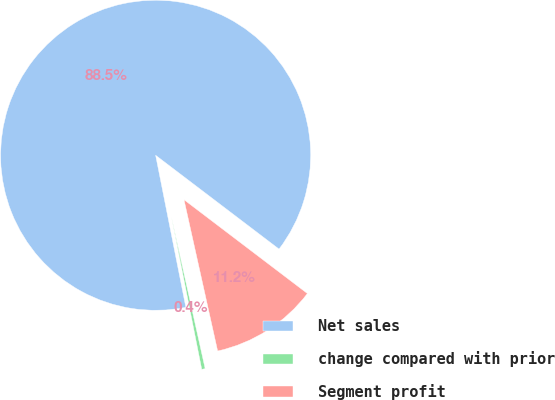Convert chart to OTSL. <chart><loc_0><loc_0><loc_500><loc_500><pie_chart><fcel>Net sales<fcel>change compared with prior<fcel>Segment profit<nl><fcel>88.46%<fcel>0.36%<fcel>11.17%<nl></chart> 